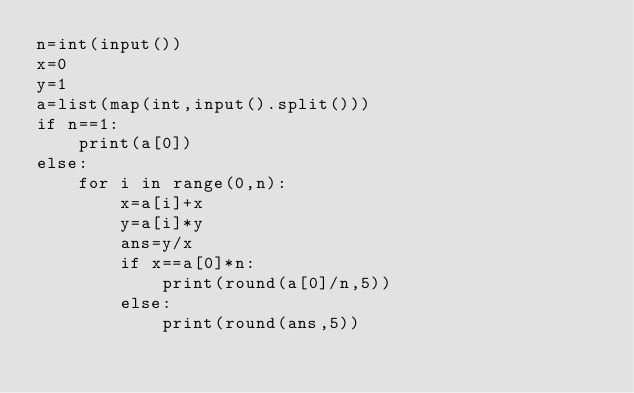Convert code to text. <code><loc_0><loc_0><loc_500><loc_500><_Python_>n=int(input())
x=0
y=1
a=list(map(int,input().split()))
if n==1:
    print(a[0])
else:
    for i in range(0,n):
        x=a[i]+x
        y=a[i]*y
        ans=y/x
        if x==a[0]*n:
            print(round(a[0]/n,5))
        else:
            print(round(ans,5))
</code> 